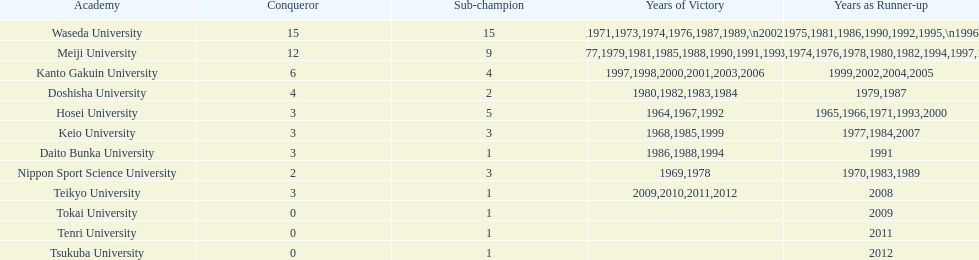Who won the last championship recorded on this table? Teikyo University. 